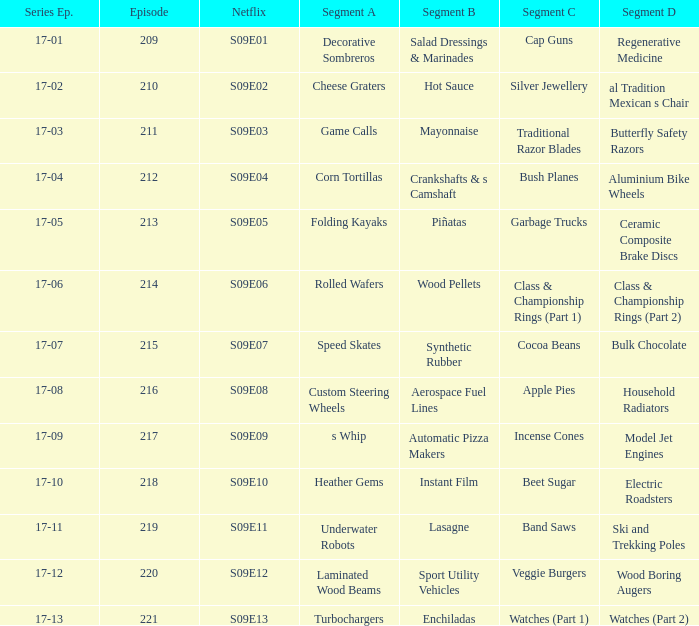What is the relationship between segment a and segment b in aerospace fuel lines? Custom Steering Wheels. 